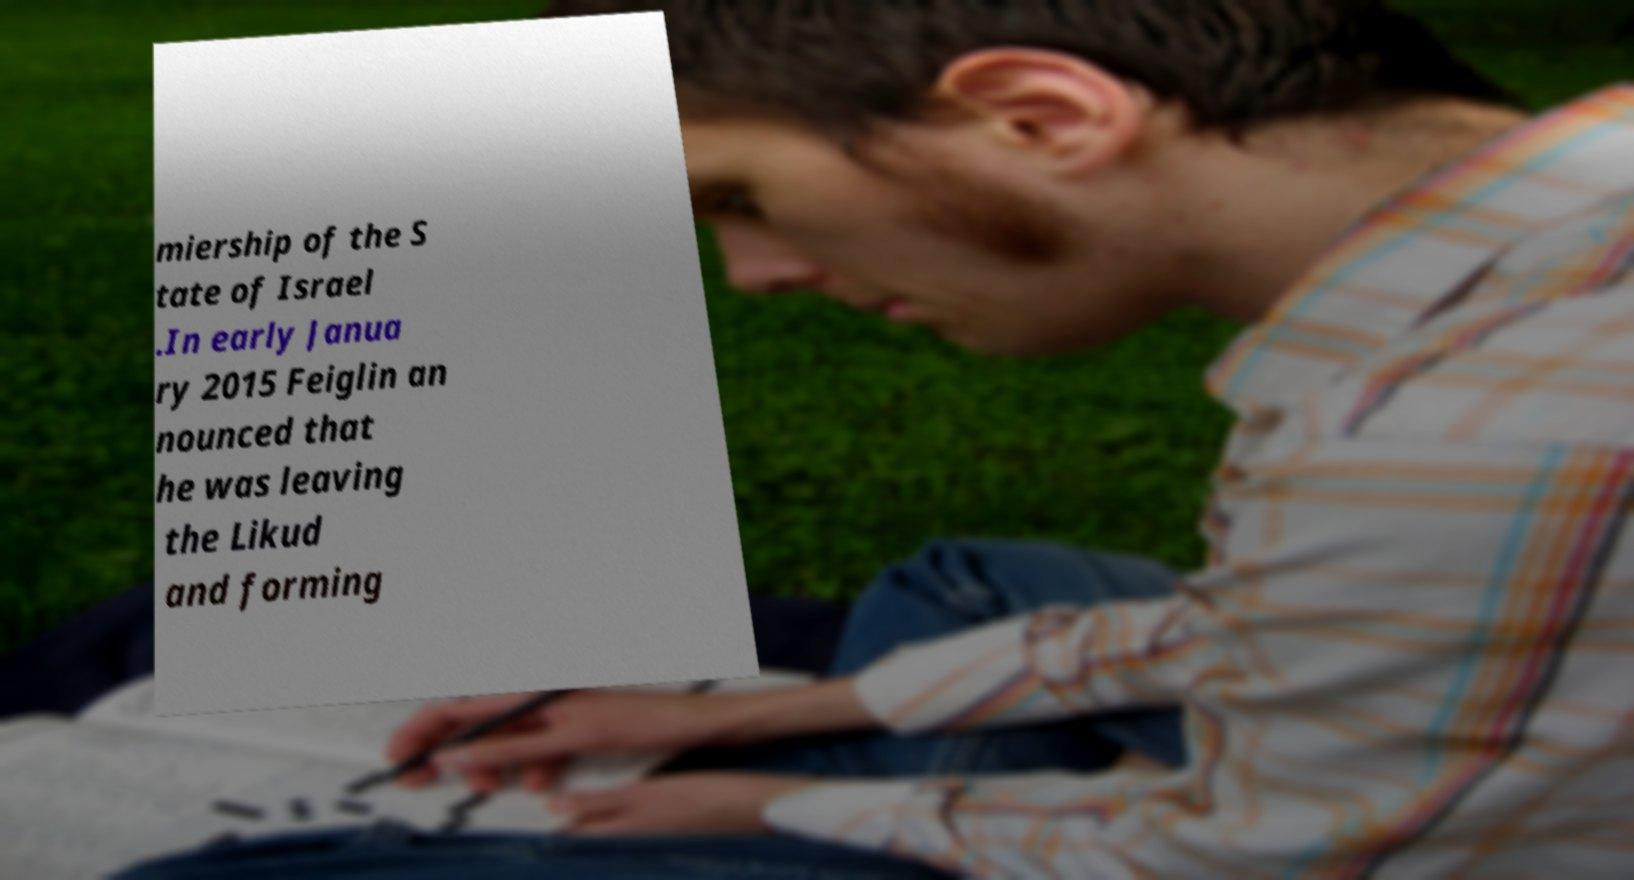What messages or text are displayed in this image? I need them in a readable, typed format. miership of the S tate of Israel .In early Janua ry 2015 Feiglin an nounced that he was leaving the Likud and forming 